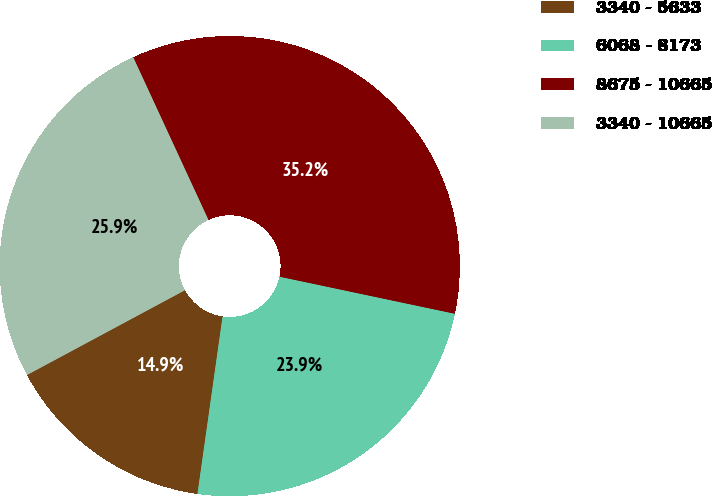Convert chart to OTSL. <chart><loc_0><loc_0><loc_500><loc_500><pie_chart><fcel>3340 - 5633<fcel>6068 - 8173<fcel>8675 - 10665<fcel>3340 - 10665<nl><fcel>14.92%<fcel>23.92%<fcel>35.21%<fcel>25.95%<nl></chart> 